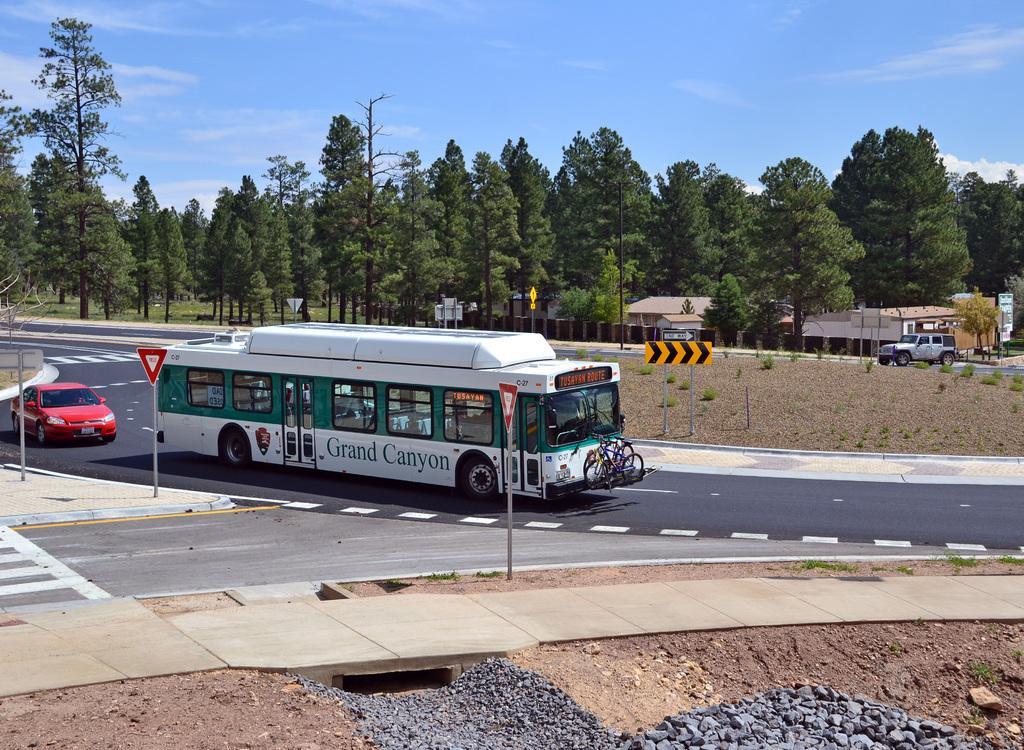Could you give a brief overview of what you see in this image? In the middle a bus is moving on a road. It is in white color. Behind this a car is also there which is in red color and in the middle there are green color trees. At the top it's a sunny sky. 